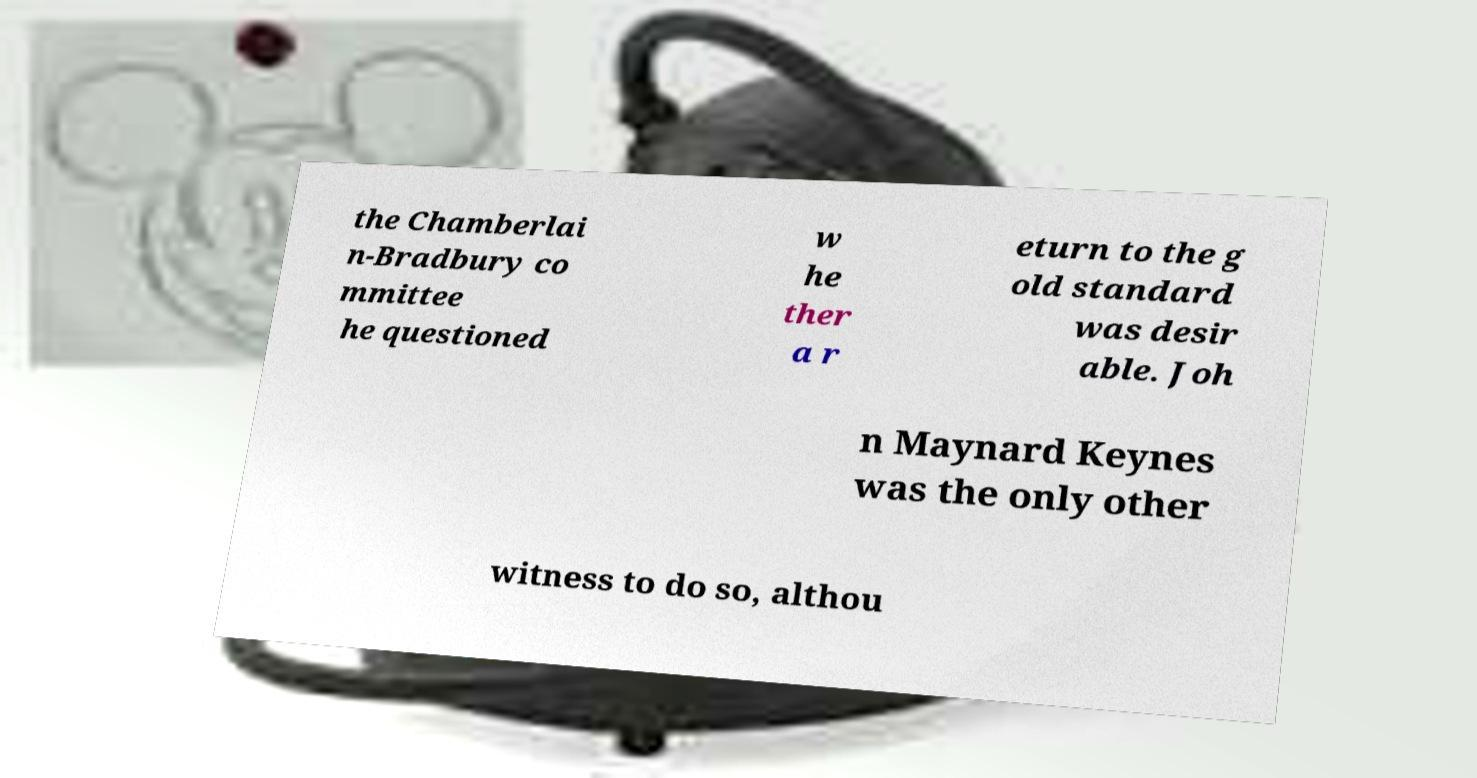I need the written content from this picture converted into text. Can you do that? the Chamberlai n-Bradbury co mmittee he questioned w he ther a r eturn to the g old standard was desir able. Joh n Maynard Keynes was the only other witness to do so, althou 